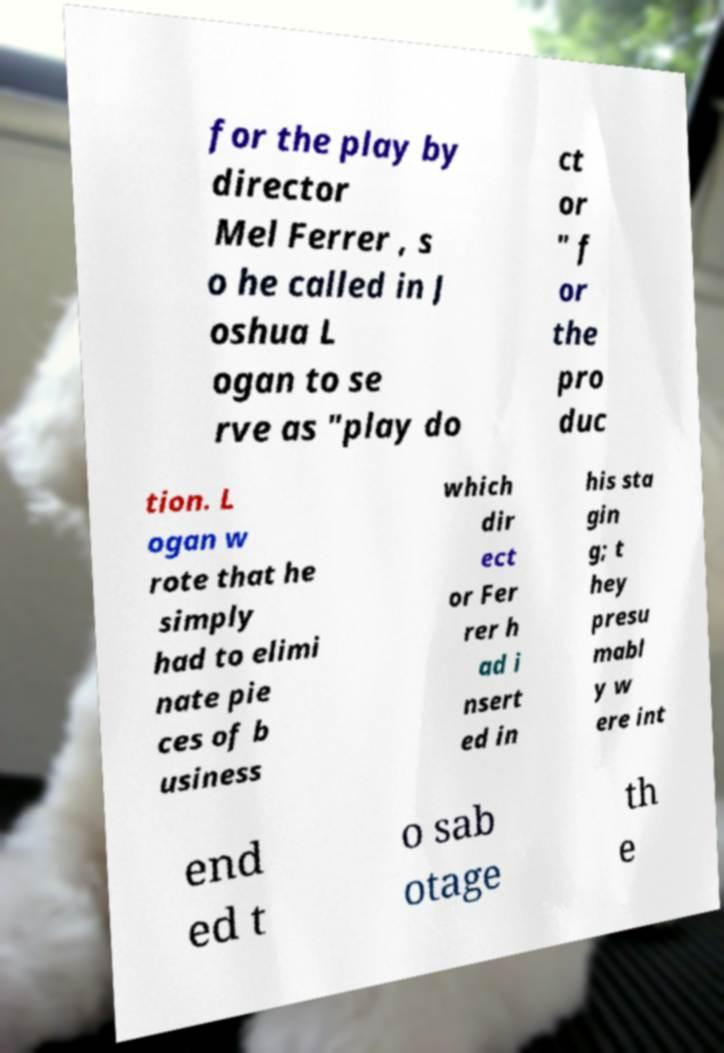For documentation purposes, I need the text within this image transcribed. Could you provide that? for the play by director Mel Ferrer , s o he called in J oshua L ogan to se rve as "play do ct or " f or the pro duc tion. L ogan w rote that he simply had to elimi nate pie ces of b usiness which dir ect or Fer rer h ad i nsert ed in his sta gin g; t hey presu mabl y w ere int end ed t o sab otage th e 